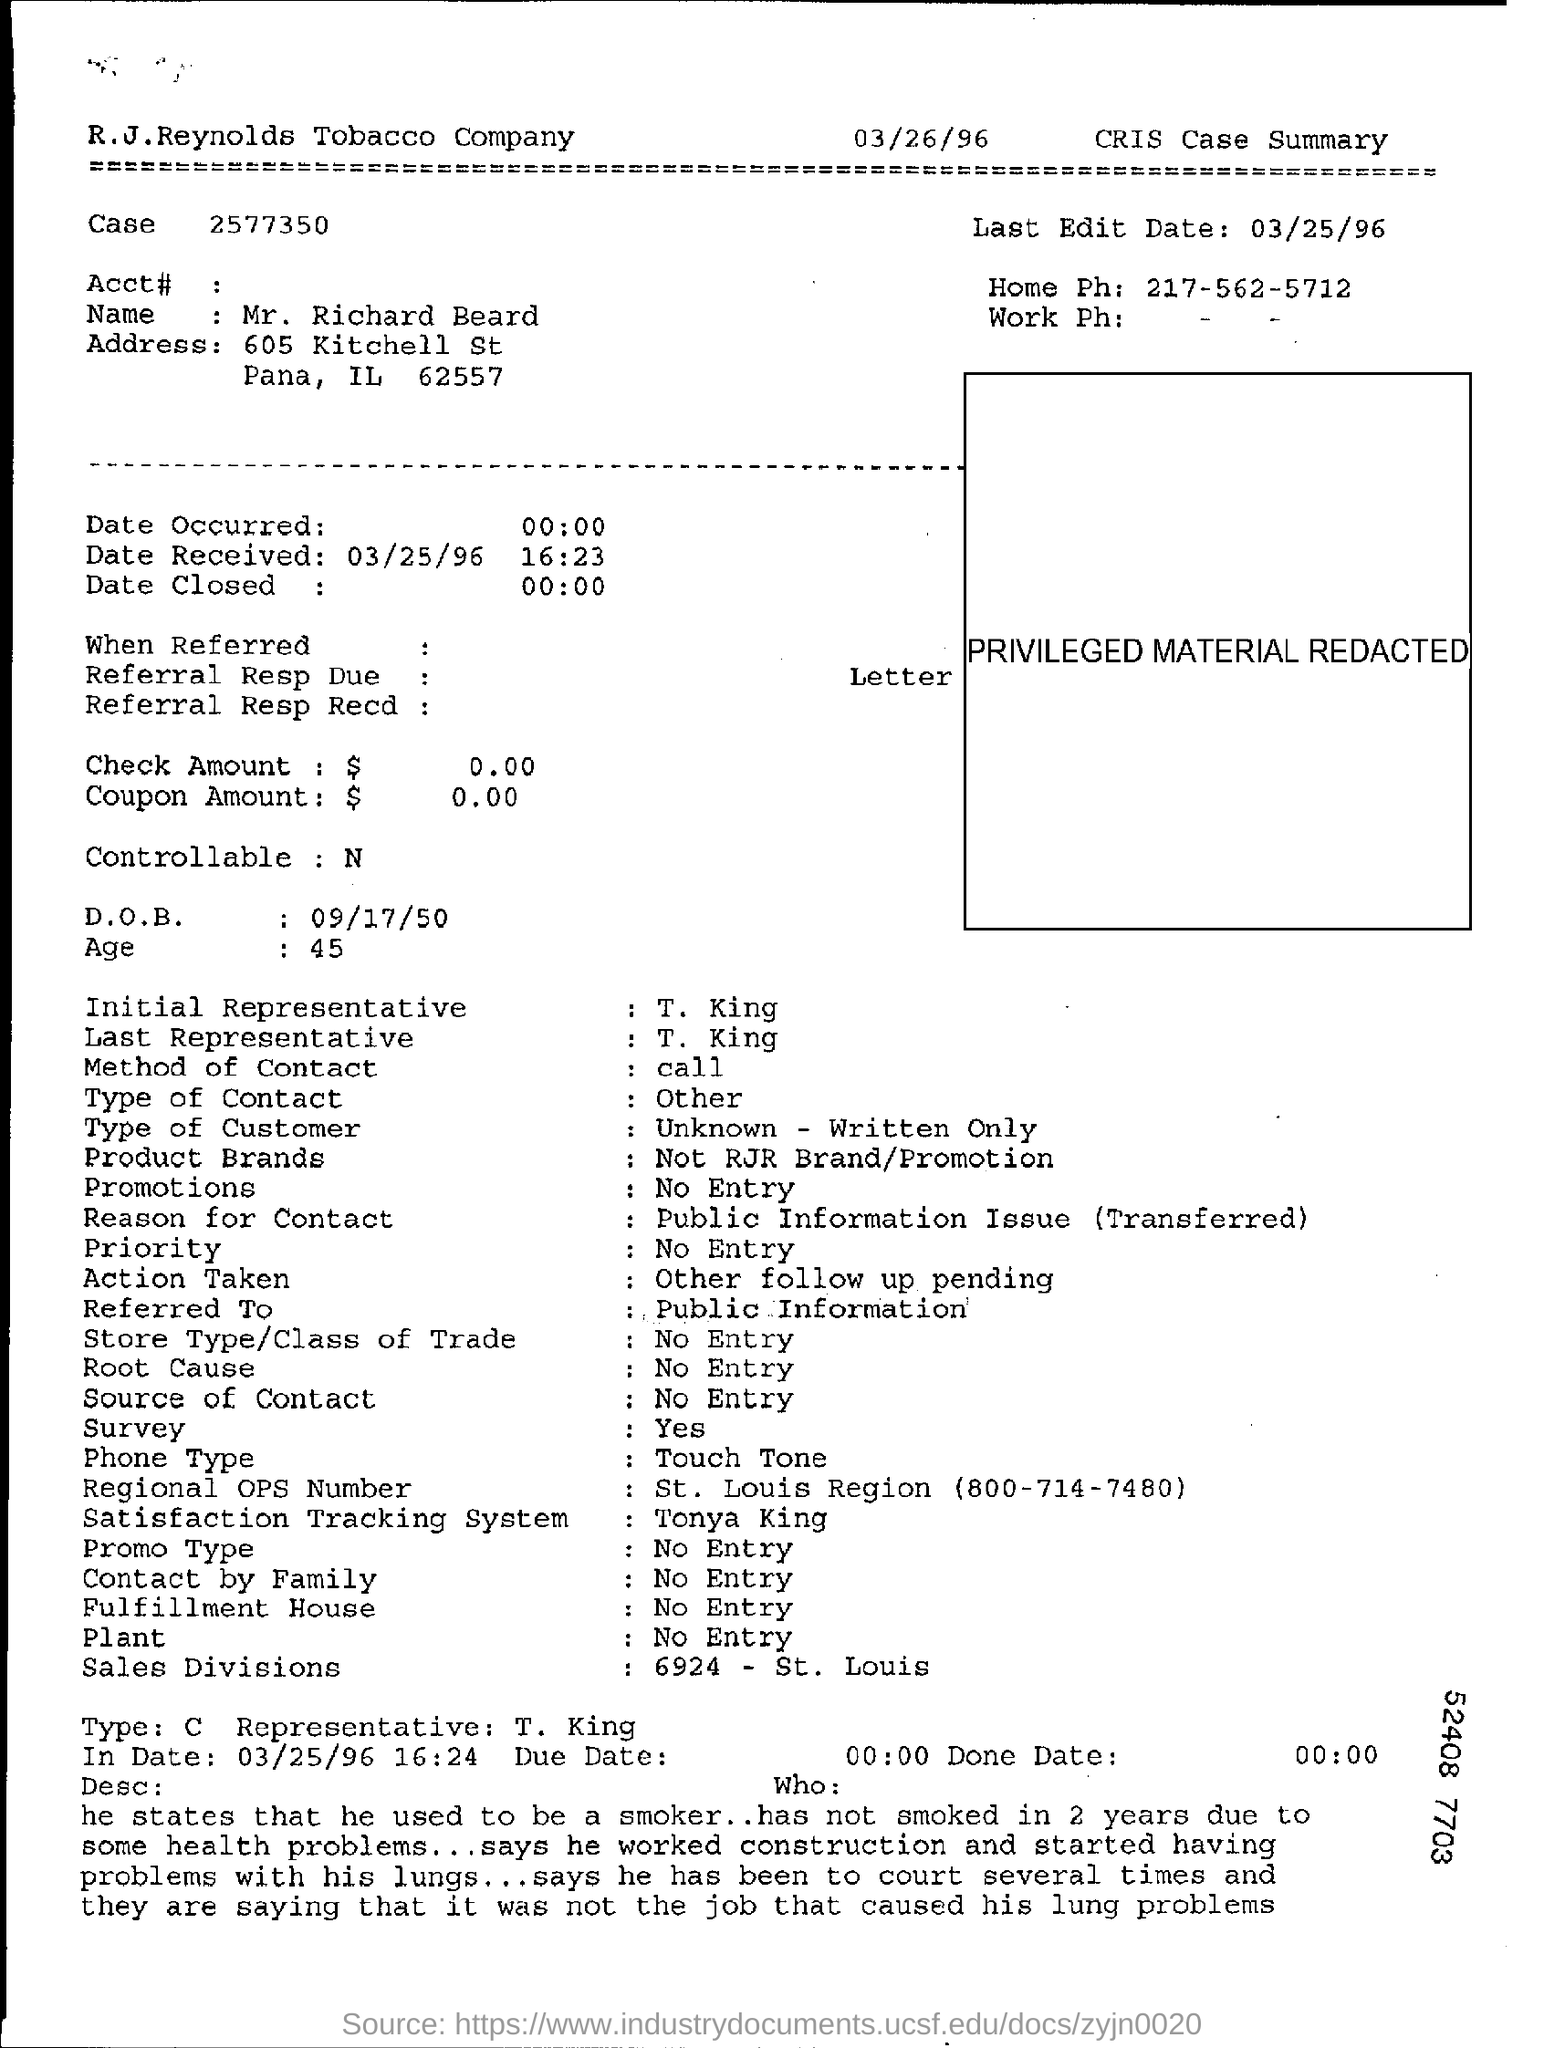Who is initial representative mentioned in the document?
Your response must be concise. T. King. Who is last representative mentioned in the document?
Make the answer very short. T. King. What is the method of contact mentioned in the document?
Offer a very short reply. Call. Why the person hasn't smoked for 2 years?
Provide a short and direct response. Due to some health problems. What is the name of the company?
Your answer should be compact. R.J.Reynolds Tobacco Company. What is last Edit date mentioned?
Give a very brief answer. 03/25/96. What is DOB mentioned in the document?
Provide a succinct answer. 09/17/50. What is Age mentioned?
Give a very brief answer. 45. 